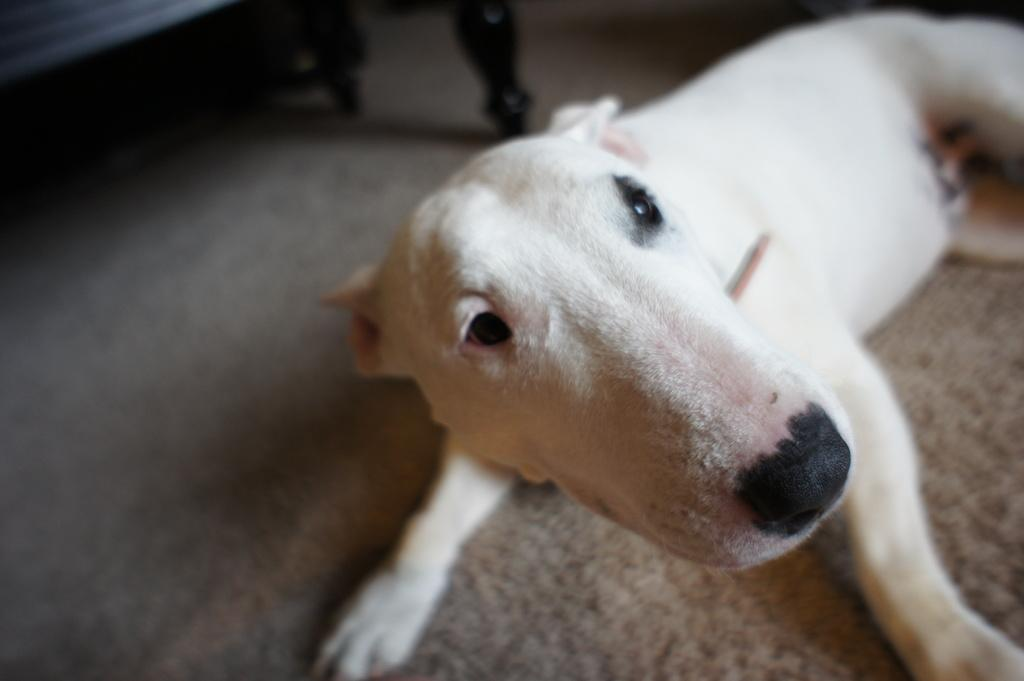What animal can be seen in the picture? There is a dog in the picture. Where is the dog located in the image? The dog is on the floor. What type of furniture is visible in the top left side of the picture? There appears to be a wooden bench on the top left side of the picture. How many thumbs does the dog have in the picture? Dogs do not have thumbs, so this question cannot be answered based on the image. 